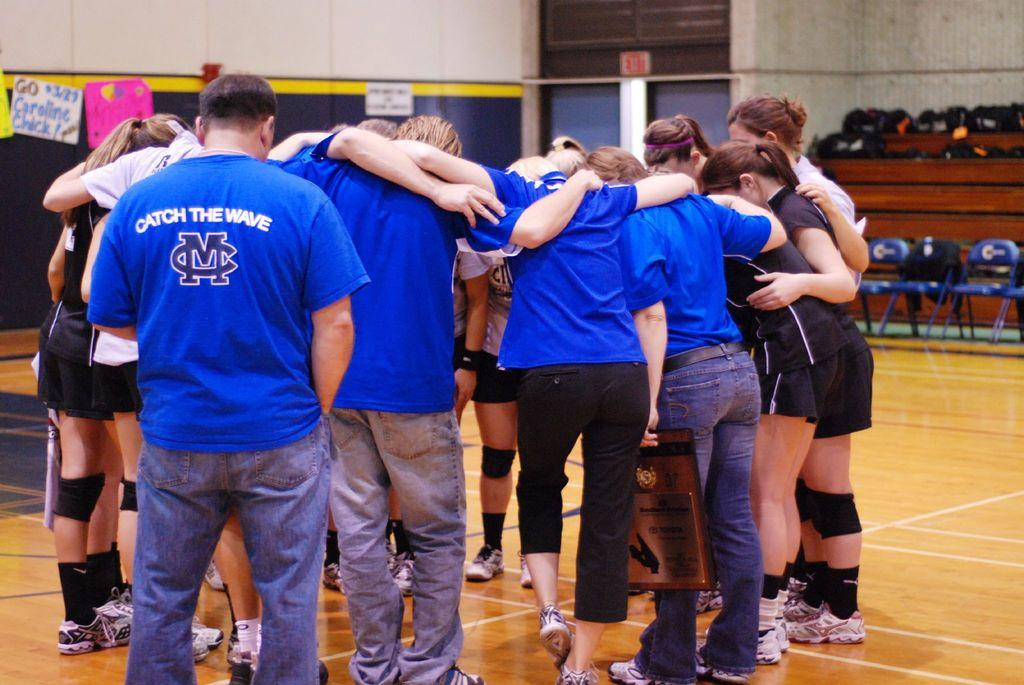What is happening in the image? There are people standing in the image. Can you describe the clothing of some of the people? Some of the people are wearing blue color t-shirts. Where is the girl located in the image? The girl is standing on the right side of the image. What color is the girl's t-shirt? The girl is wearing a black color t-shirt. How are the people positioned in the image? All the people are standing together. How many planes can be seen flying in the image? There are no planes visible in the image; it only shows people standing together. Are there any snails crawling on the people's clothes in the image? A: There are no snails present in the image. 